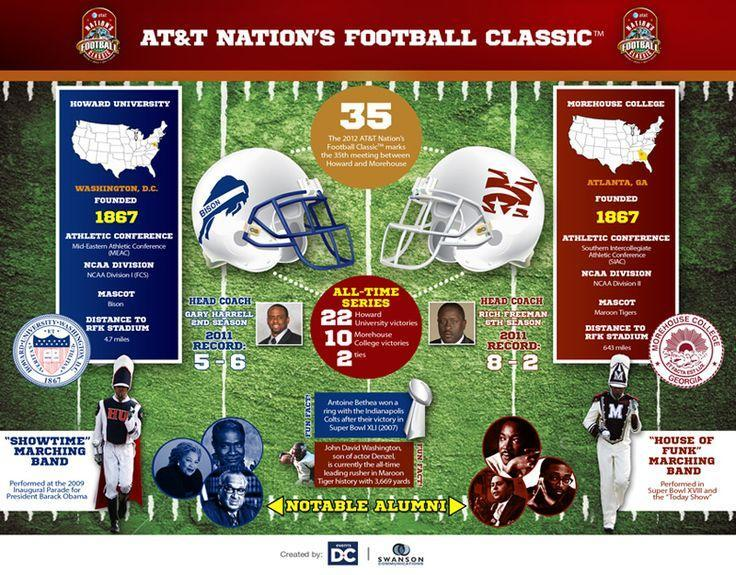when was morehouse college founded
Answer the question with a short phrase. 1867 how many notable alumini are shown in howard university 3 who is the head coach of morehouse college Rich Freeman what is the mascot of howard university bison which state is in morehouse college atlanta, ga who performed for Barack Obama "showtime" marching band 